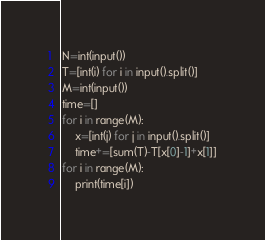<code> <loc_0><loc_0><loc_500><loc_500><_Python_>N=int(input())
T=[int(i) for i in input().split()]
M=int(input())
time=[]
for i in range(M):
    x=[int(j) for j in input().split()]
    time+=[sum(T)-T[x[0]-1]+x[1]]
for i in range(M):
    print(time[i])</code> 